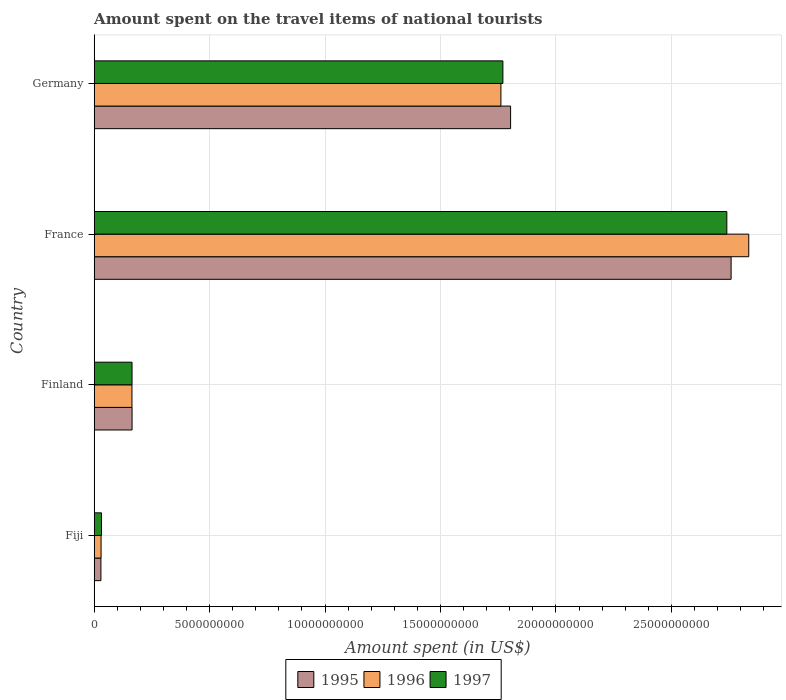How many groups of bars are there?
Make the answer very short. 4. Are the number of bars per tick equal to the number of legend labels?
Keep it short and to the point. Yes. Are the number of bars on each tick of the Y-axis equal?
Keep it short and to the point. Yes. How many bars are there on the 1st tick from the bottom?
Give a very brief answer. 3. What is the label of the 4th group of bars from the top?
Keep it short and to the point. Fiji. In how many cases, is the number of bars for a given country not equal to the number of legend labels?
Offer a very short reply. 0. What is the amount spent on the travel items of national tourists in 1995 in Germany?
Your response must be concise. 1.80e+1. Across all countries, what is the maximum amount spent on the travel items of national tourists in 1997?
Your answer should be compact. 2.74e+1. Across all countries, what is the minimum amount spent on the travel items of national tourists in 1995?
Make the answer very short. 2.91e+08. In which country was the amount spent on the travel items of national tourists in 1996 maximum?
Offer a very short reply. France. In which country was the amount spent on the travel items of national tourists in 1995 minimum?
Your response must be concise. Fiji. What is the total amount spent on the travel items of national tourists in 1995 in the graph?
Ensure brevity in your answer.  4.76e+1. What is the difference between the amount spent on the travel items of national tourists in 1995 in Fiji and that in Finland?
Keep it short and to the point. -1.35e+09. What is the difference between the amount spent on the travel items of national tourists in 1997 in Fiji and the amount spent on the travel items of national tourists in 1995 in Germany?
Your response must be concise. -1.77e+1. What is the average amount spent on the travel items of national tourists in 1997 per country?
Your response must be concise. 1.18e+1. What is the difference between the amount spent on the travel items of national tourists in 1995 and amount spent on the travel items of national tourists in 1996 in France?
Offer a very short reply. -7.65e+08. In how many countries, is the amount spent on the travel items of national tourists in 1995 greater than 3000000000 US$?
Ensure brevity in your answer.  2. What is the ratio of the amount spent on the travel items of national tourists in 1996 in France to that in Germany?
Make the answer very short. 1.61. What is the difference between the highest and the second highest amount spent on the travel items of national tourists in 1995?
Your answer should be very brief. 9.55e+09. What is the difference between the highest and the lowest amount spent on the travel items of national tourists in 1995?
Provide a succinct answer. 2.73e+1. In how many countries, is the amount spent on the travel items of national tourists in 1995 greater than the average amount spent on the travel items of national tourists in 1995 taken over all countries?
Keep it short and to the point. 2. Is the sum of the amount spent on the travel items of national tourists in 1997 in Finland and France greater than the maximum amount spent on the travel items of national tourists in 1996 across all countries?
Provide a succinct answer. Yes. What does the 2nd bar from the top in France represents?
Give a very brief answer. 1996. Is it the case that in every country, the sum of the amount spent on the travel items of national tourists in 1995 and amount spent on the travel items of national tourists in 1996 is greater than the amount spent on the travel items of national tourists in 1997?
Offer a terse response. Yes. How many bars are there?
Offer a terse response. 12. How many countries are there in the graph?
Keep it short and to the point. 4. What is the difference between two consecutive major ticks on the X-axis?
Make the answer very short. 5.00e+09. Where does the legend appear in the graph?
Keep it short and to the point. Bottom center. How are the legend labels stacked?
Ensure brevity in your answer.  Horizontal. What is the title of the graph?
Keep it short and to the point. Amount spent on the travel items of national tourists. What is the label or title of the X-axis?
Keep it short and to the point. Amount spent (in US$). What is the label or title of the Y-axis?
Keep it short and to the point. Country. What is the Amount spent (in US$) in 1995 in Fiji?
Your answer should be very brief. 2.91e+08. What is the Amount spent (in US$) in 1996 in Fiji?
Give a very brief answer. 2.98e+08. What is the Amount spent (in US$) in 1997 in Fiji?
Give a very brief answer. 3.17e+08. What is the Amount spent (in US$) in 1995 in Finland?
Keep it short and to the point. 1.64e+09. What is the Amount spent (in US$) of 1996 in Finland?
Give a very brief answer. 1.64e+09. What is the Amount spent (in US$) in 1997 in Finland?
Provide a succinct answer. 1.64e+09. What is the Amount spent (in US$) in 1995 in France?
Offer a very short reply. 2.76e+1. What is the Amount spent (in US$) in 1996 in France?
Give a very brief answer. 2.84e+1. What is the Amount spent (in US$) in 1997 in France?
Make the answer very short. 2.74e+1. What is the Amount spent (in US$) of 1995 in Germany?
Your answer should be very brief. 1.80e+1. What is the Amount spent (in US$) in 1996 in Germany?
Provide a succinct answer. 1.76e+1. What is the Amount spent (in US$) of 1997 in Germany?
Ensure brevity in your answer.  1.77e+1. Across all countries, what is the maximum Amount spent (in US$) of 1995?
Your answer should be compact. 2.76e+1. Across all countries, what is the maximum Amount spent (in US$) of 1996?
Your answer should be compact. 2.84e+1. Across all countries, what is the maximum Amount spent (in US$) in 1997?
Your answer should be compact. 2.74e+1. Across all countries, what is the minimum Amount spent (in US$) in 1995?
Offer a terse response. 2.91e+08. Across all countries, what is the minimum Amount spent (in US$) of 1996?
Provide a short and direct response. 2.98e+08. Across all countries, what is the minimum Amount spent (in US$) of 1997?
Provide a succinct answer. 3.17e+08. What is the total Amount spent (in US$) of 1995 in the graph?
Your answer should be very brief. 4.76e+1. What is the total Amount spent (in US$) in 1996 in the graph?
Your answer should be very brief. 4.79e+1. What is the total Amount spent (in US$) of 1997 in the graph?
Ensure brevity in your answer.  4.71e+1. What is the difference between the Amount spent (in US$) in 1995 in Fiji and that in Finland?
Provide a short and direct response. -1.35e+09. What is the difference between the Amount spent (in US$) in 1996 in Fiji and that in Finland?
Your response must be concise. -1.34e+09. What is the difference between the Amount spent (in US$) of 1997 in Fiji and that in Finland?
Your answer should be very brief. -1.32e+09. What is the difference between the Amount spent (in US$) in 1995 in Fiji and that in France?
Offer a terse response. -2.73e+1. What is the difference between the Amount spent (in US$) in 1996 in Fiji and that in France?
Keep it short and to the point. -2.81e+1. What is the difference between the Amount spent (in US$) in 1997 in Fiji and that in France?
Give a very brief answer. -2.71e+1. What is the difference between the Amount spent (in US$) in 1995 in Fiji and that in Germany?
Your response must be concise. -1.77e+1. What is the difference between the Amount spent (in US$) in 1996 in Fiji and that in Germany?
Your response must be concise. -1.73e+1. What is the difference between the Amount spent (in US$) of 1997 in Fiji and that in Germany?
Your answer should be compact. -1.74e+1. What is the difference between the Amount spent (in US$) of 1995 in Finland and that in France?
Your response must be concise. -2.59e+1. What is the difference between the Amount spent (in US$) of 1996 in Finland and that in France?
Keep it short and to the point. -2.67e+1. What is the difference between the Amount spent (in US$) of 1997 in Finland and that in France?
Ensure brevity in your answer.  -2.58e+1. What is the difference between the Amount spent (in US$) in 1995 in Finland and that in Germany?
Provide a short and direct response. -1.64e+1. What is the difference between the Amount spent (in US$) of 1996 in Finland and that in Germany?
Your answer should be compact. -1.60e+1. What is the difference between the Amount spent (in US$) of 1997 in Finland and that in Germany?
Your response must be concise. -1.61e+1. What is the difference between the Amount spent (in US$) in 1995 in France and that in Germany?
Offer a terse response. 9.55e+09. What is the difference between the Amount spent (in US$) of 1996 in France and that in Germany?
Make the answer very short. 1.07e+1. What is the difference between the Amount spent (in US$) of 1997 in France and that in Germany?
Make the answer very short. 9.70e+09. What is the difference between the Amount spent (in US$) in 1995 in Fiji and the Amount spent (in US$) in 1996 in Finland?
Keep it short and to the point. -1.34e+09. What is the difference between the Amount spent (in US$) of 1995 in Fiji and the Amount spent (in US$) of 1997 in Finland?
Give a very brief answer. -1.35e+09. What is the difference between the Amount spent (in US$) of 1996 in Fiji and the Amount spent (in US$) of 1997 in Finland?
Your answer should be compact. -1.34e+09. What is the difference between the Amount spent (in US$) of 1995 in Fiji and the Amount spent (in US$) of 1996 in France?
Provide a succinct answer. -2.81e+1. What is the difference between the Amount spent (in US$) of 1995 in Fiji and the Amount spent (in US$) of 1997 in France?
Offer a terse response. -2.71e+1. What is the difference between the Amount spent (in US$) in 1996 in Fiji and the Amount spent (in US$) in 1997 in France?
Your response must be concise. -2.71e+1. What is the difference between the Amount spent (in US$) in 1995 in Fiji and the Amount spent (in US$) in 1996 in Germany?
Your answer should be very brief. -1.73e+1. What is the difference between the Amount spent (in US$) in 1995 in Fiji and the Amount spent (in US$) in 1997 in Germany?
Make the answer very short. -1.74e+1. What is the difference between the Amount spent (in US$) of 1996 in Fiji and the Amount spent (in US$) of 1997 in Germany?
Your response must be concise. -1.74e+1. What is the difference between the Amount spent (in US$) in 1995 in Finland and the Amount spent (in US$) in 1996 in France?
Give a very brief answer. -2.67e+1. What is the difference between the Amount spent (in US$) of 1995 in Finland and the Amount spent (in US$) of 1997 in France?
Give a very brief answer. -2.58e+1. What is the difference between the Amount spent (in US$) of 1996 in Finland and the Amount spent (in US$) of 1997 in France?
Offer a very short reply. -2.58e+1. What is the difference between the Amount spent (in US$) of 1995 in Finland and the Amount spent (in US$) of 1996 in Germany?
Your response must be concise. -1.60e+1. What is the difference between the Amount spent (in US$) of 1995 in Finland and the Amount spent (in US$) of 1997 in Germany?
Your answer should be very brief. -1.61e+1. What is the difference between the Amount spent (in US$) of 1996 in Finland and the Amount spent (in US$) of 1997 in Germany?
Your answer should be compact. -1.61e+1. What is the difference between the Amount spent (in US$) in 1995 in France and the Amount spent (in US$) in 1996 in Germany?
Keep it short and to the point. 9.97e+09. What is the difference between the Amount spent (in US$) in 1995 in France and the Amount spent (in US$) in 1997 in Germany?
Keep it short and to the point. 9.88e+09. What is the difference between the Amount spent (in US$) in 1996 in France and the Amount spent (in US$) in 1997 in Germany?
Ensure brevity in your answer.  1.06e+1. What is the average Amount spent (in US$) of 1995 per country?
Ensure brevity in your answer.  1.19e+1. What is the average Amount spent (in US$) of 1996 per country?
Provide a short and direct response. 1.20e+1. What is the average Amount spent (in US$) in 1997 per country?
Provide a short and direct response. 1.18e+1. What is the difference between the Amount spent (in US$) in 1995 and Amount spent (in US$) in 1996 in Fiji?
Ensure brevity in your answer.  -7.00e+06. What is the difference between the Amount spent (in US$) in 1995 and Amount spent (in US$) in 1997 in Fiji?
Keep it short and to the point. -2.60e+07. What is the difference between the Amount spent (in US$) in 1996 and Amount spent (in US$) in 1997 in Fiji?
Offer a very short reply. -1.90e+07. What is the difference between the Amount spent (in US$) of 1995 and Amount spent (in US$) of 1996 in France?
Your answer should be compact. -7.65e+08. What is the difference between the Amount spent (in US$) in 1995 and Amount spent (in US$) in 1997 in France?
Make the answer very short. 1.85e+08. What is the difference between the Amount spent (in US$) in 1996 and Amount spent (in US$) in 1997 in France?
Your response must be concise. 9.50e+08. What is the difference between the Amount spent (in US$) in 1995 and Amount spent (in US$) in 1996 in Germany?
Offer a terse response. 4.20e+08. What is the difference between the Amount spent (in US$) in 1995 and Amount spent (in US$) in 1997 in Germany?
Your answer should be very brief. 3.34e+08. What is the difference between the Amount spent (in US$) in 1996 and Amount spent (in US$) in 1997 in Germany?
Your response must be concise. -8.60e+07. What is the ratio of the Amount spent (in US$) of 1995 in Fiji to that in Finland?
Keep it short and to the point. 0.18. What is the ratio of the Amount spent (in US$) in 1996 in Fiji to that in Finland?
Keep it short and to the point. 0.18. What is the ratio of the Amount spent (in US$) of 1997 in Fiji to that in Finland?
Provide a short and direct response. 0.19. What is the ratio of the Amount spent (in US$) in 1995 in Fiji to that in France?
Provide a succinct answer. 0.01. What is the ratio of the Amount spent (in US$) in 1996 in Fiji to that in France?
Your answer should be compact. 0.01. What is the ratio of the Amount spent (in US$) of 1997 in Fiji to that in France?
Provide a succinct answer. 0.01. What is the ratio of the Amount spent (in US$) in 1995 in Fiji to that in Germany?
Offer a terse response. 0.02. What is the ratio of the Amount spent (in US$) in 1996 in Fiji to that in Germany?
Offer a very short reply. 0.02. What is the ratio of the Amount spent (in US$) in 1997 in Fiji to that in Germany?
Provide a short and direct response. 0.02. What is the ratio of the Amount spent (in US$) in 1995 in Finland to that in France?
Your response must be concise. 0.06. What is the ratio of the Amount spent (in US$) of 1996 in Finland to that in France?
Give a very brief answer. 0.06. What is the ratio of the Amount spent (in US$) of 1997 in Finland to that in France?
Provide a succinct answer. 0.06. What is the ratio of the Amount spent (in US$) in 1995 in Finland to that in Germany?
Your response must be concise. 0.09. What is the ratio of the Amount spent (in US$) in 1996 in Finland to that in Germany?
Your answer should be compact. 0.09. What is the ratio of the Amount spent (in US$) of 1997 in Finland to that in Germany?
Your answer should be very brief. 0.09. What is the ratio of the Amount spent (in US$) of 1995 in France to that in Germany?
Ensure brevity in your answer.  1.53. What is the ratio of the Amount spent (in US$) of 1996 in France to that in Germany?
Provide a succinct answer. 1.61. What is the ratio of the Amount spent (in US$) in 1997 in France to that in Germany?
Your response must be concise. 1.55. What is the difference between the highest and the second highest Amount spent (in US$) of 1995?
Make the answer very short. 9.55e+09. What is the difference between the highest and the second highest Amount spent (in US$) in 1996?
Make the answer very short. 1.07e+1. What is the difference between the highest and the second highest Amount spent (in US$) of 1997?
Provide a short and direct response. 9.70e+09. What is the difference between the highest and the lowest Amount spent (in US$) in 1995?
Provide a succinct answer. 2.73e+1. What is the difference between the highest and the lowest Amount spent (in US$) of 1996?
Give a very brief answer. 2.81e+1. What is the difference between the highest and the lowest Amount spent (in US$) of 1997?
Offer a very short reply. 2.71e+1. 